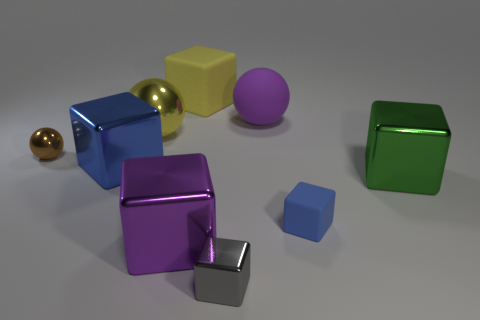Subtract 2 blocks. How many blocks are left? 4 Subtract all gray blocks. How many blocks are left? 5 Subtract all tiny metal blocks. How many blocks are left? 5 Subtract all gray blocks. Subtract all brown balls. How many blocks are left? 5 Subtract all spheres. How many objects are left? 6 Subtract all small green matte spheres. Subtract all big metallic spheres. How many objects are left? 8 Add 6 big purple balls. How many big purple balls are left? 7 Add 5 green metal objects. How many green metal objects exist? 6 Subtract 1 green blocks. How many objects are left? 8 